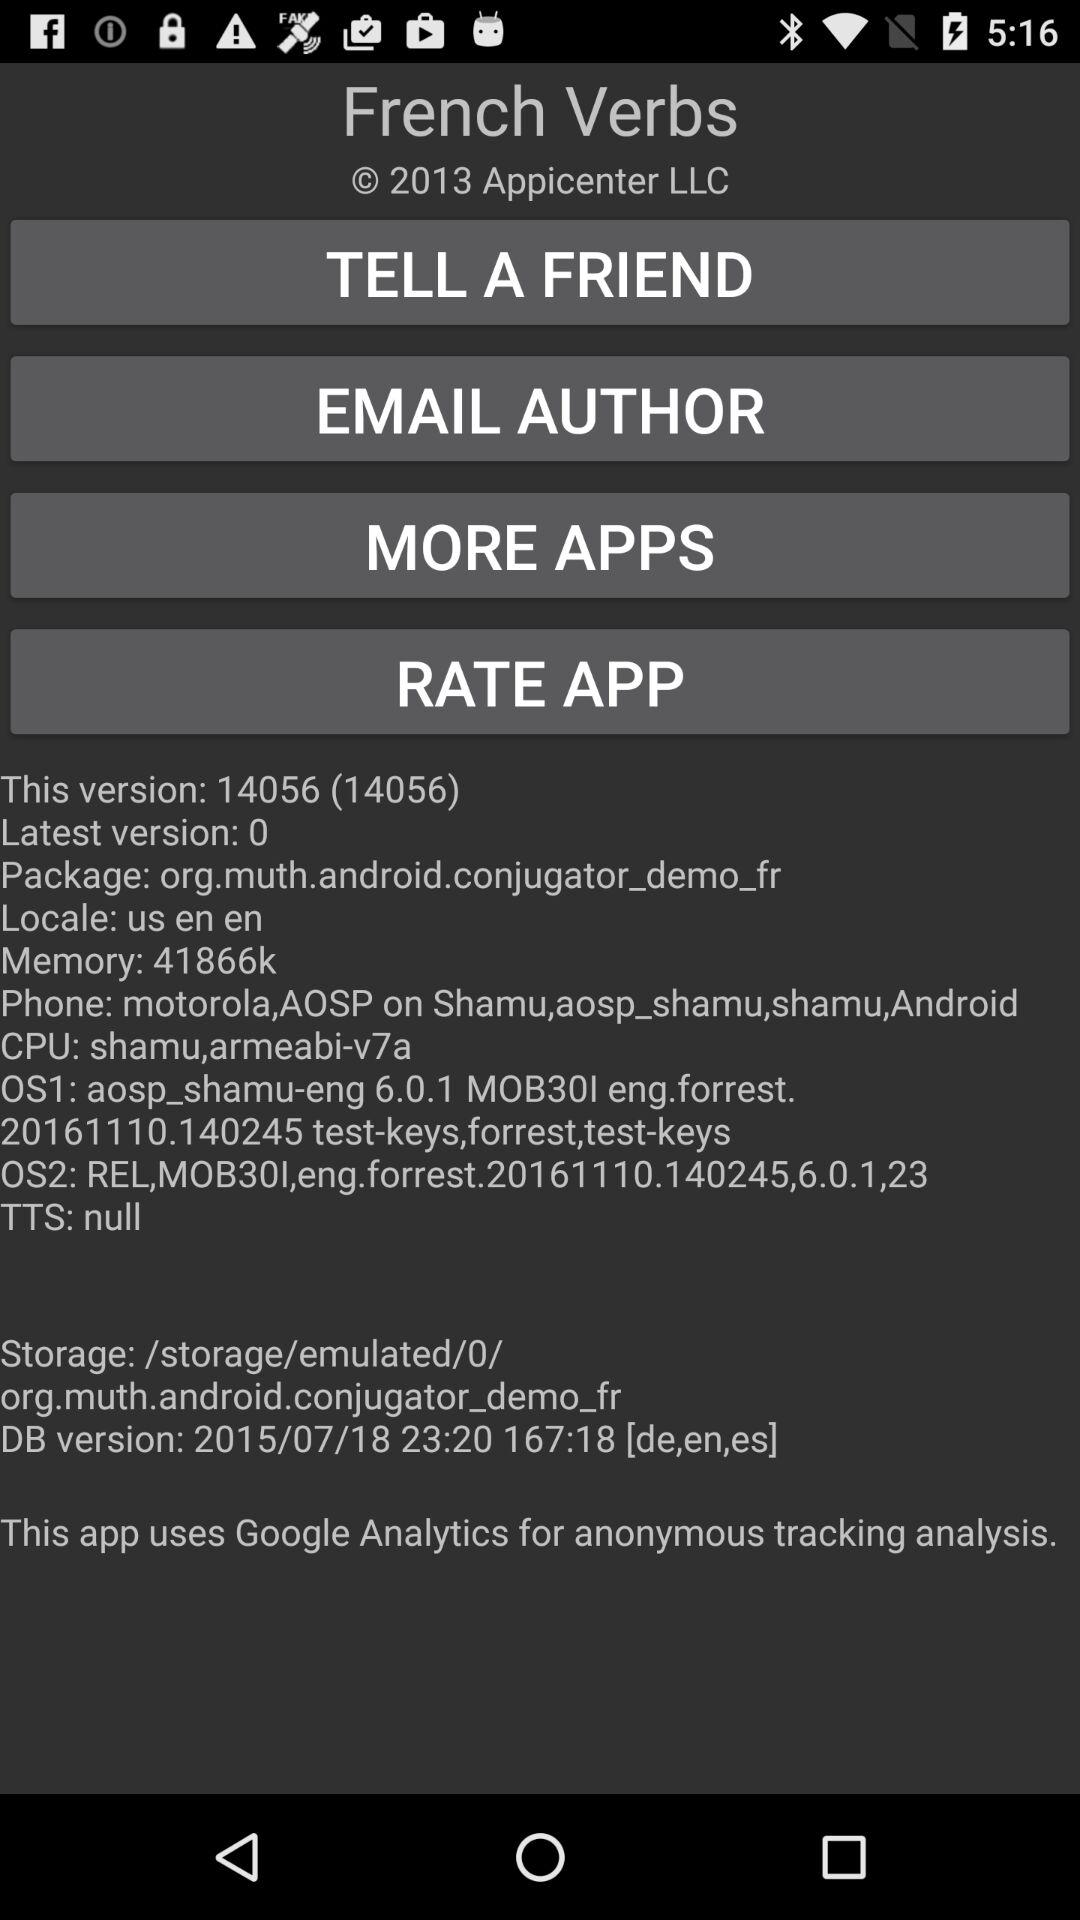What is the version of the app that is installed?
Answer the question using a single word or phrase. 14056 (14056) 